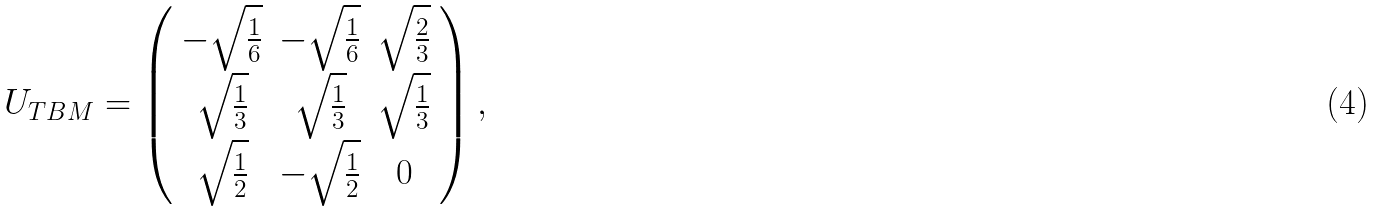Convert formula to latex. <formula><loc_0><loc_0><loc_500><loc_500>U _ { T B M } = \left ( \begin{array} { c c c } - \sqrt { \frac { 1 } { 6 } } & - \sqrt { \frac { 1 } { 6 } } & \sqrt { \frac { 2 } { 3 } } \\ \sqrt { \frac { 1 } { 3 } } & \sqrt { \frac { 1 } { 3 } } & \sqrt { \frac { 1 } { 3 } } \\ \sqrt { \frac { 1 } { 2 } } & - \sqrt { \frac { 1 } { 2 } } & 0 \end{array} \right ) ,</formula> 